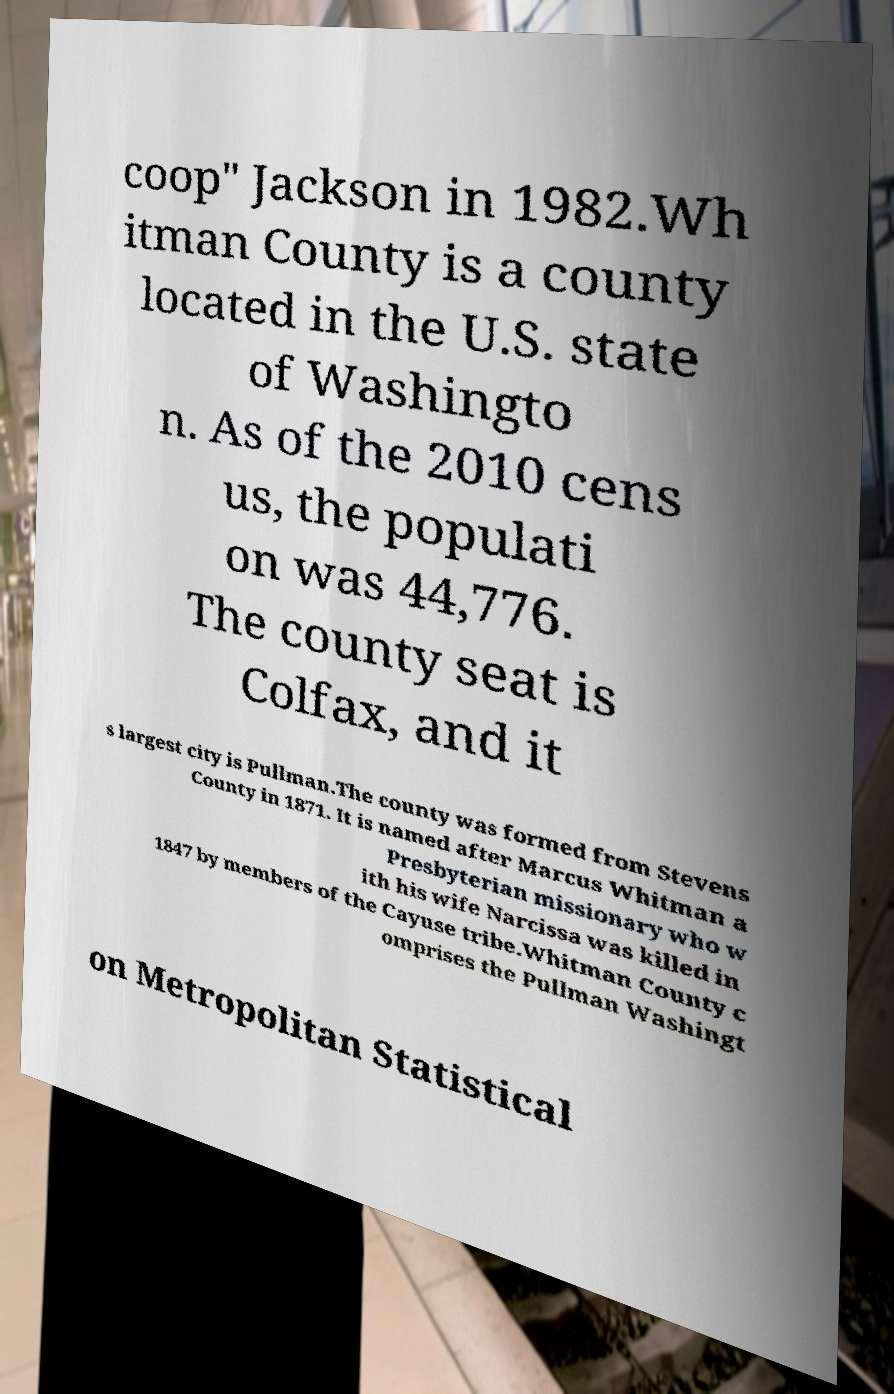Can you accurately transcribe the text from the provided image for me? coop" Jackson in 1982.Wh itman County is a county located in the U.S. state of Washingto n. As of the 2010 cens us, the populati on was 44,776. The county seat is Colfax, and it s largest city is Pullman.The county was formed from Stevens County in 1871. It is named after Marcus Whitman a Presbyterian missionary who w ith his wife Narcissa was killed in 1847 by members of the Cayuse tribe.Whitman County c omprises the Pullman Washingt on Metropolitan Statistical 